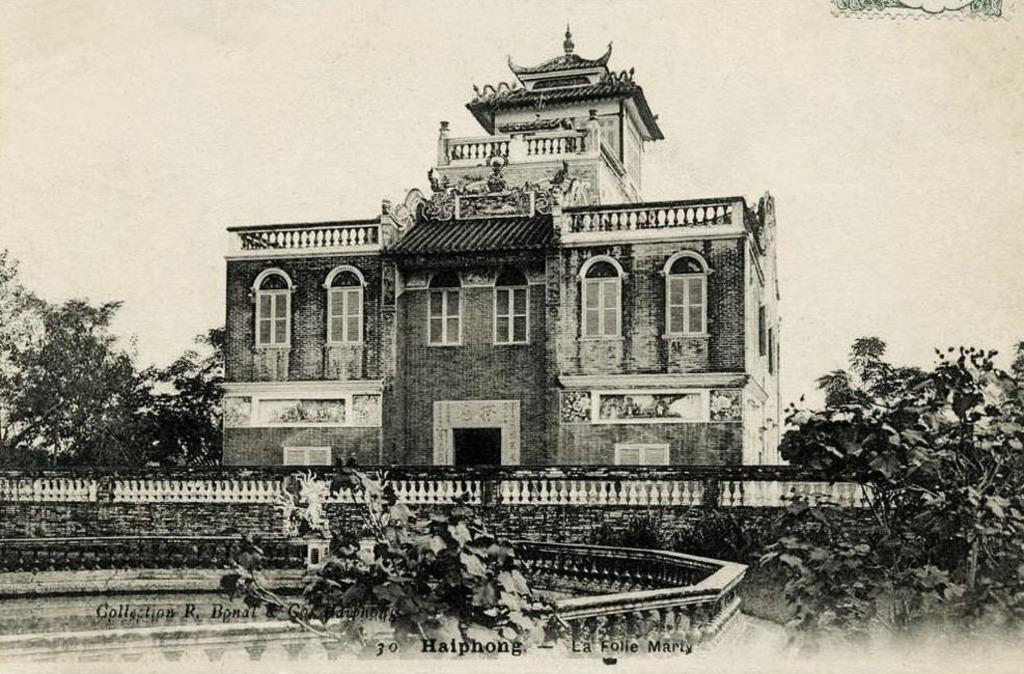Can you describe this image briefly? In this picture we can see a building, windows. We can see trees and plants. At the bottom portion of the picture there is something written in black letters. 